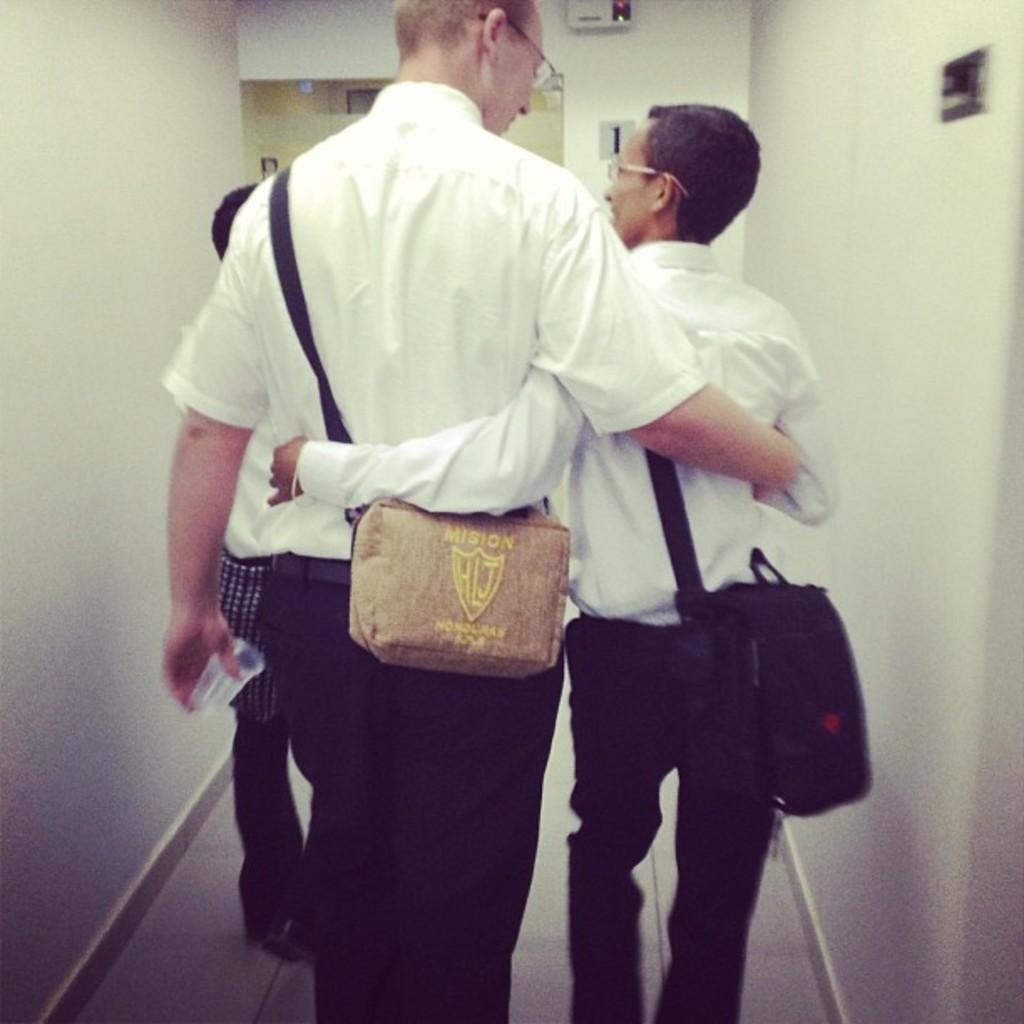In one or two sentences, can you explain what this image depicts? This is a picture of two people holding each other wearing backpacks and white color shirts. 